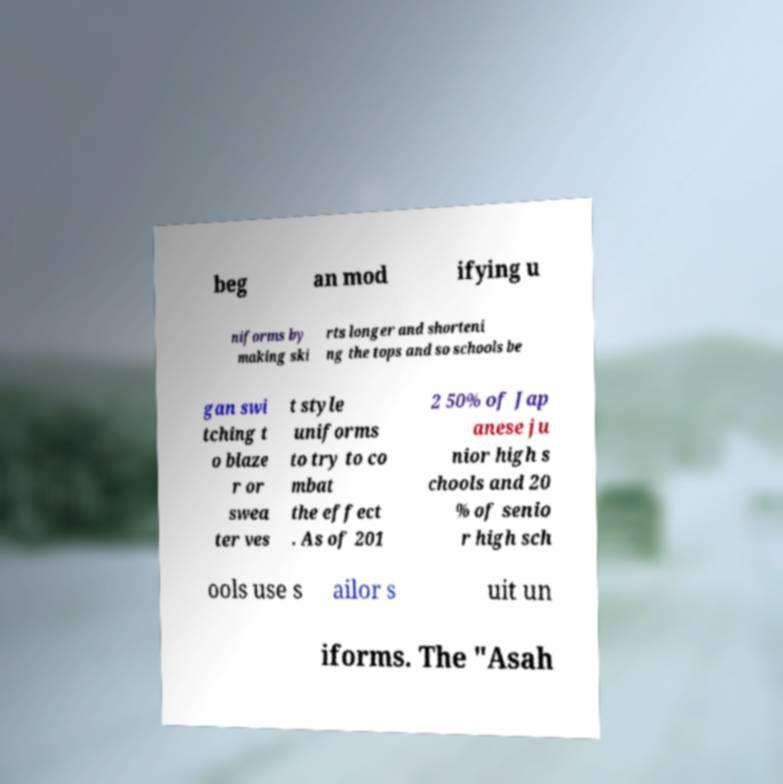Please identify and transcribe the text found in this image. beg an mod ifying u niforms by making ski rts longer and shorteni ng the tops and so schools be gan swi tching t o blaze r or swea ter ves t style uniforms to try to co mbat the effect . As of 201 2 50% of Jap anese ju nior high s chools and 20 % of senio r high sch ools use s ailor s uit un iforms. The "Asah 